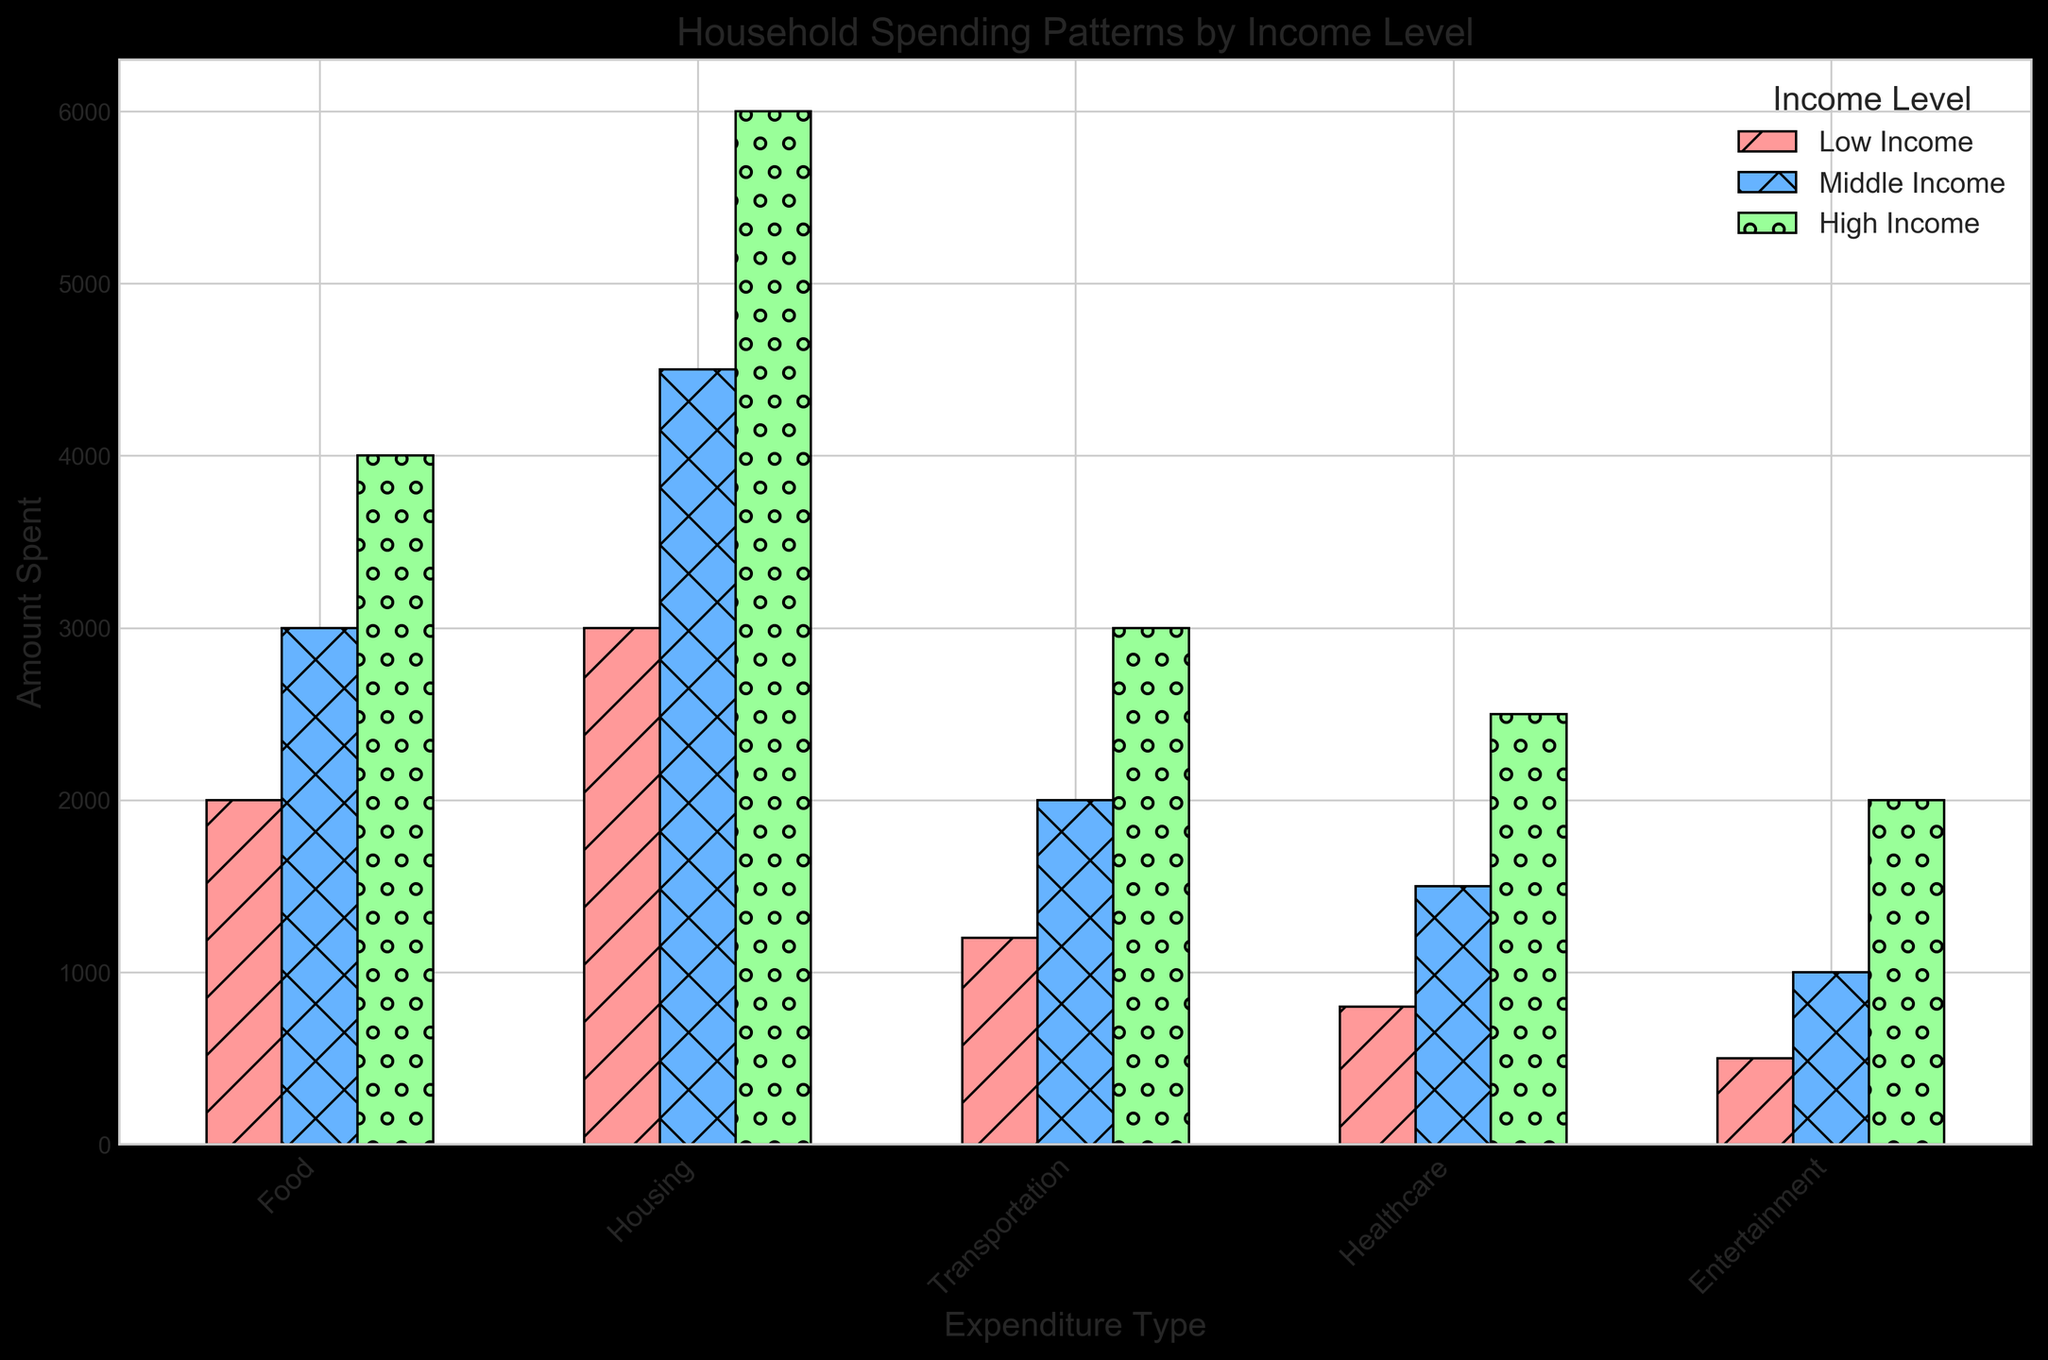What is the total expenditure on Food across all income levels? To find the total expenditure on Food, sum the amounts for Food from all income levels: 2000 (Low Income) + 3000 (Middle Income) + 4000 (High Income). The calculation is 2000 + 3000 + 4000 = 9000.
Answer: 9000 Which income level spends the most on Housing? By comparing the heights of the bars representing Housing expenditure for each income level, High Income has the tallest bar (6000), followed by Middle Income (4500), and then Low Income (3000).
Answer: High Income How does the amount spent on Entertainment differ between Middle Income and Low Income households? Subtract the amount spent by Low Income on Entertainment from the amount spent by Middle Income on Entertainment: 1000 (Middle Income) - 500 (Low Income). The calculation is 1000 - 500 = 500.
Answer: 500 Which type of expenditure sees the smallest difference in spending between Low Income and High Income households? Calculate the difference for each expenditure type: 
Food: 4000 - 2000 = 2000
Housing: 6000 - 3000 = 3000
Transportation: 3000 - 1200 = 1800
Healthcare: 2500 - 800 = 1700
Entertainment: 2000 - 500 = 1500
The smallest difference is seen in Entertainment.
Answer: Entertainment What is the average amount spent on Healthcare across all income levels? Add the amounts spent on Healthcare by each income level, then divide by the number of income levels: (800 + 1500 + 2500) / 3. The calculation is (800 + 1500 + 2500) / 3 = 1600.
Answer: 1600 Which income level spends the least on Transportation? By comparing the heights of the bars representing Transportation expenditure for each income level, Low Income has the shortest bar (1200).
Answer: Low Income How much more do High Income households spend on Healthcare compared to Low Income households? Subtract the amount spent by Low Income on Healthcare from the amount spent by High Income on Healthcare: 2500 - 800. The calculation is 2500 - 800 = 1700.
Answer: 1700 What is the total expenditure on all types of expenditure for Middle Income households? Sum the amounts for all expenditure types for Middle Income: 3000 (Food) + 4500 (Housing) + 2000 (Transportation) + 1500 (Healthcare) + 1000 (Entertainment). The calculation is 3000 + 4500 + 2000 + 1500 + 1000 = 12000.
Answer: 12000 